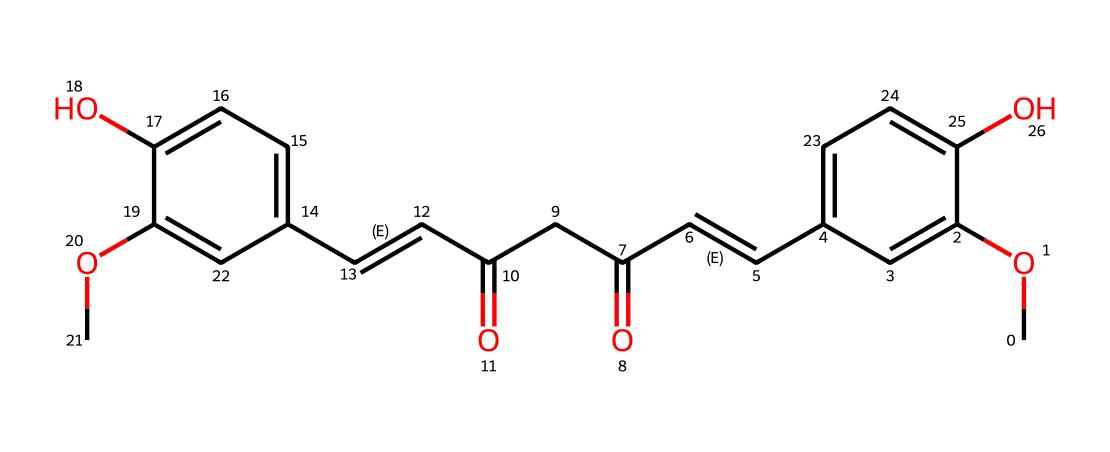What is the main functional group present in curcumin? The structure shows the presence of phenolic -OH (hydroxyl) groups, indicated by the -O and the -OH attachments to the aromatic rings.
Answer: hydroxyl How many double bonds are present in the chemical structure? By analyzing the structure, two double bonds are found in the main chain (C=C), and there are two additional ones in the cyclic rings, totaling four.
Answer: four What type of molecule is curcumin classified as? The molecular structure indicates that curcumin has multiple aromatic rings and functional groups, classifying it as a polyphenol.
Answer: polyphenol How many carbon atoms are in the curcumin molecule? Counting the carbon atoms (C) in the SMILES structure reveals a total of 21 carbon atoms in the whole molecule.
Answer: 21 Which part of the molecule contributes to its yellow color? The extensive conjugation present in the structure allows for visible light absorption, especially within the phenolic framework.
Answer: conjugation Are there any methoxy groups in the structure? Observing the chemical shows -OCH3 attachments connected to the aromatic rings, confirming the presence of methoxy groups.
Answer: yes 